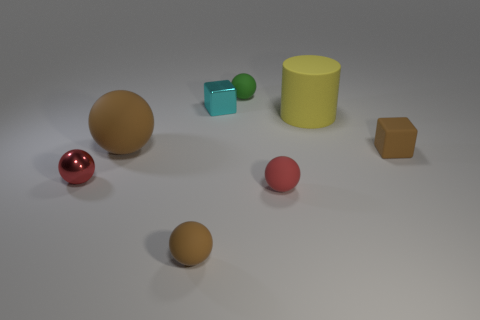Are there the same number of tiny spheres that are in front of the tiny green rubber ball and tiny gray shiny cubes?
Provide a short and direct response. No. How many other shiny blocks have the same color as the shiny cube?
Your answer should be very brief. 0. There is a shiny object that is the same shape as the small red rubber object; what color is it?
Provide a short and direct response. Red. Is the size of the yellow object the same as the red metal ball?
Keep it short and to the point. No. Is the number of red balls in front of the small red metal object the same as the number of tiny rubber cubes that are to the right of the yellow object?
Offer a terse response. Yes. Are any big gray shiny cubes visible?
Keep it short and to the point. No. What is the size of the green matte object that is the same shape as the tiny red matte thing?
Offer a very short reply. Small. What is the size of the red object that is in front of the red shiny thing?
Offer a terse response. Small. Is the number of big rubber spheres that are on the left side of the red metallic sphere greater than the number of red things?
Offer a very short reply. No. What shape is the green rubber thing?
Provide a short and direct response. Sphere. 